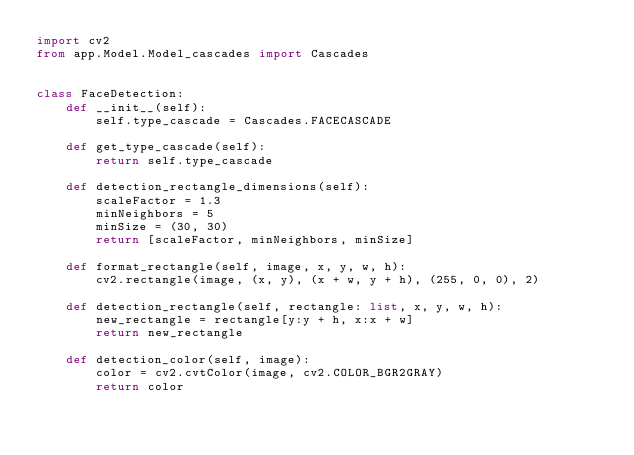Convert code to text. <code><loc_0><loc_0><loc_500><loc_500><_Python_>import cv2
from app.Model.Model_cascades import Cascades


class FaceDetection:
    def __init__(self):
        self.type_cascade = Cascades.FACECASCADE

    def get_type_cascade(self):
        return self.type_cascade

    def detection_rectangle_dimensions(self):
        scaleFactor = 1.3
        minNeighbors = 5
        minSize = (30, 30)
        return [scaleFactor, minNeighbors, minSize]

    def format_rectangle(self, image, x, y, w, h):
        cv2.rectangle(image, (x, y), (x + w, y + h), (255, 0, 0), 2)

    def detection_rectangle(self, rectangle: list, x, y, w, h):
        new_rectangle = rectangle[y:y + h, x:x + w]
        return new_rectangle

    def detection_color(self, image):
        color = cv2.cvtColor(image, cv2.COLOR_BGR2GRAY)
        return color
</code> 